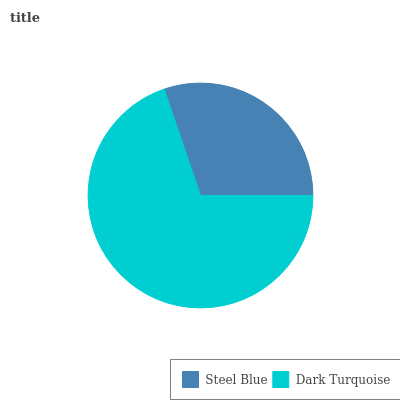Is Steel Blue the minimum?
Answer yes or no. Yes. Is Dark Turquoise the maximum?
Answer yes or no. Yes. Is Dark Turquoise the minimum?
Answer yes or no. No. Is Dark Turquoise greater than Steel Blue?
Answer yes or no. Yes. Is Steel Blue less than Dark Turquoise?
Answer yes or no. Yes. Is Steel Blue greater than Dark Turquoise?
Answer yes or no. No. Is Dark Turquoise less than Steel Blue?
Answer yes or no. No. Is Dark Turquoise the high median?
Answer yes or no. Yes. Is Steel Blue the low median?
Answer yes or no. Yes. Is Steel Blue the high median?
Answer yes or no. No. Is Dark Turquoise the low median?
Answer yes or no. No. 